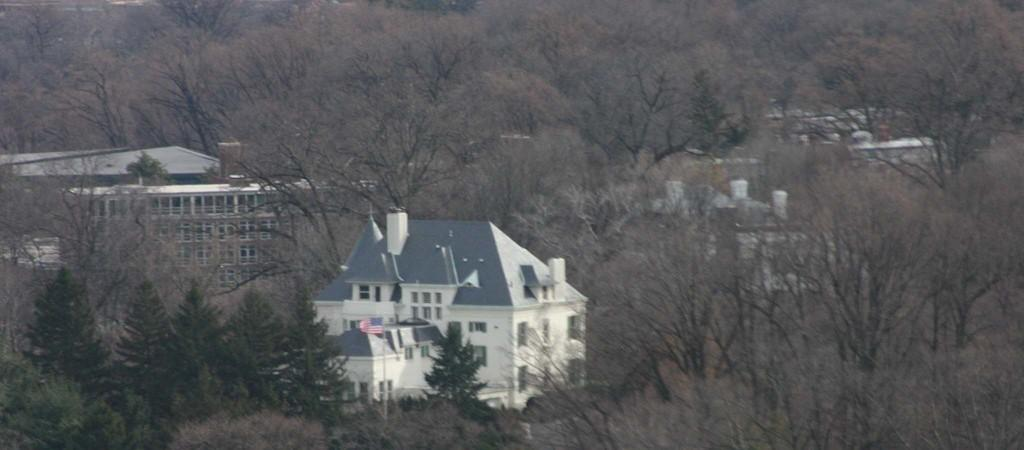What type of structures can be seen in the image? There are buildings in the image. What feature is present on the buildings? There are windows in the image. What is the symbolic object in the image? There is a flag in the image. What type of natural elements are visible in the image? There are trees in the image. What type of store can be seen in the image? There is no store present in the image; it features buildings, windows, a flag, and trees. What type of sheet is covering the trees in the image? There is no sheet covering the trees in the image; the trees are visible without any covering. 